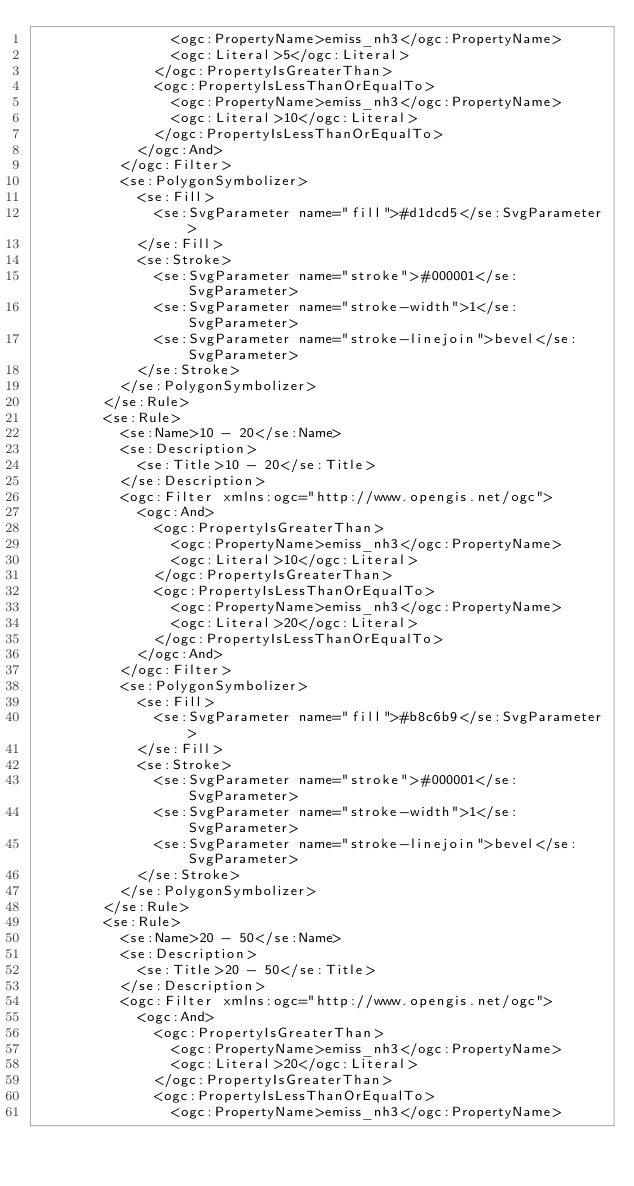Convert code to text. <code><loc_0><loc_0><loc_500><loc_500><_Scheme_>                <ogc:PropertyName>emiss_nh3</ogc:PropertyName>
                <ogc:Literal>5</ogc:Literal>
              </ogc:PropertyIsGreaterThan>
              <ogc:PropertyIsLessThanOrEqualTo>
                <ogc:PropertyName>emiss_nh3</ogc:PropertyName>
                <ogc:Literal>10</ogc:Literal>
              </ogc:PropertyIsLessThanOrEqualTo>
            </ogc:And>
          </ogc:Filter>
          <se:PolygonSymbolizer>
            <se:Fill>
              <se:SvgParameter name="fill">#d1dcd5</se:SvgParameter>
            </se:Fill>
            <se:Stroke>
              <se:SvgParameter name="stroke">#000001</se:SvgParameter>
              <se:SvgParameter name="stroke-width">1</se:SvgParameter>
              <se:SvgParameter name="stroke-linejoin">bevel</se:SvgParameter>
            </se:Stroke>
          </se:PolygonSymbolizer>
        </se:Rule>
        <se:Rule>
          <se:Name>10 - 20</se:Name>
          <se:Description>
            <se:Title>10 - 20</se:Title>
          </se:Description>
          <ogc:Filter xmlns:ogc="http://www.opengis.net/ogc">
            <ogc:And>
              <ogc:PropertyIsGreaterThan>
                <ogc:PropertyName>emiss_nh3</ogc:PropertyName>
                <ogc:Literal>10</ogc:Literal>
              </ogc:PropertyIsGreaterThan>
              <ogc:PropertyIsLessThanOrEqualTo>
                <ogc:PropertyName>emiss_nh3</ogc:PropertyName>
                <ogc:Literal>20</ogc:Literal>
              </ogc:PropertyIsLessThanOrEqualTo>
            </ogc:And>
          </ogc:Filter>
          <se:PolygonSymbolizer>
            <se:Fill>
              <se:SvgParameter name="fill">#b8c6b9</se:SvgParameter>
            </se:Fill>
            <se:Stroke>
              <se:SvgParameter name="stroke">#000001</se:SvgParameter>
              <se:SvgParameter name="stroke-width">1</se:SvgParameter>
              <se:SvgParameter name="stroke-linejoin">bevel</se:SvgParameter>
            </se:Stroke>
          </se:PolygonSymbolizer>
        </se:Rule>
        <se:Rule>
          <se:Name>20 - 50</se:Name>
          <se:Description>
            <se:Title>20 - 50</se:Title>
          </se:Description>
          <ogc:Filter xmlns:ogc="http://www.opengis.net/ogc">
            <ogc:And>
              <ogc:PropertyIsGreaterThan>
                <ogc:PropertyName>emiss_nh3</ogc:PropertyName>
                <ogc:Literal>20</ogc:Literal>
              </ogc:PropertyIsGreaterThan>
              <ogc:PropertyIsLessThanOrEqualTo>
                <ogc:PropertyName>emiss_nh3</ogc:PropertyName></code> 